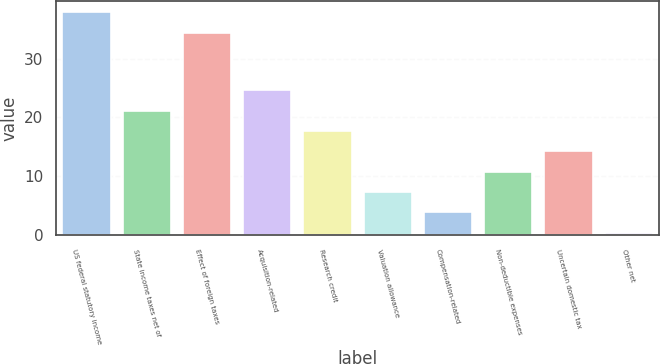<chart> <loc_0><loc_0><loc_500><loc_500><bar_chart><fcel>US federal statutory income<fcel>State income taxes net of<fcel>Effect of foreign taxes<fcel>Acquisition-related<fcel>Research credit<fcel>Valuation allowance<fcel>Compensation-related<fcel>Non-deductible expenses<fcel>Uncertain domestic tax<fcel>Other net<nl><fcel>37.86<fcel>21.16<fcel>34.4<fcel>24.62<fcel>17.7<fcel>7.32<fcel>3.86<fcel>10.78<fcel>14.24<fcel>0.4<nl></chart> 